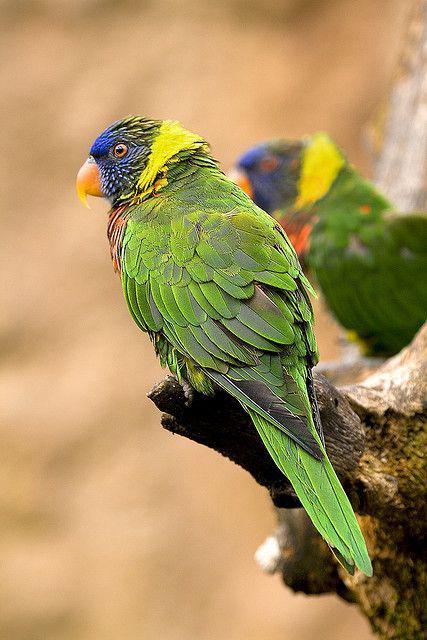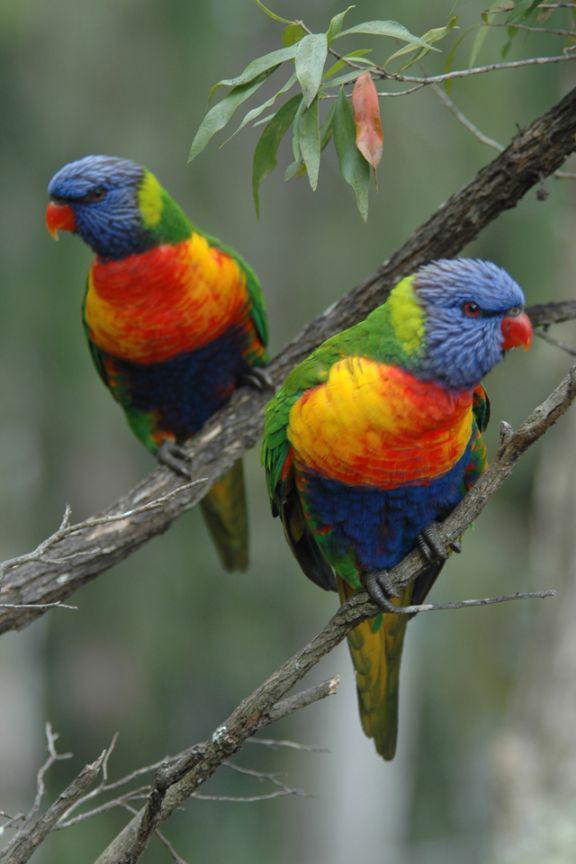The first image is the image on the left, the second image is the image on the right. Analyze the images presented: Is the assertion "The left image shows exactly three multicolored parrots." valid? Answer yes or no. No. The first image is the image on the left, the second image is the image on the right. For the images shown, is this caption "There are exactly two birds in the image on the right." true? Answer yes or no. Yes. The first image is the image on the left, the second image is the image on the right. Evaluate the accuracy of this statement regarding the images: "Three birds perch on a branch in the image on the left.". Is it true? Answer yes or no. No. 